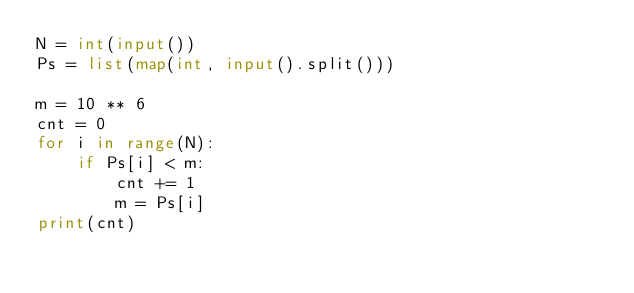Convert code to text. <code><loc_0><loc_0><loc_500><loc_500><_Python_>N = int(input())
Ps = list(map(int, input().split()))

m = 10 ** 6
cnt = 0
for i in range(N):
    if Ps[i] < m:
        cnt += 1
        m = Ps[i]
print(cnt)</code> 